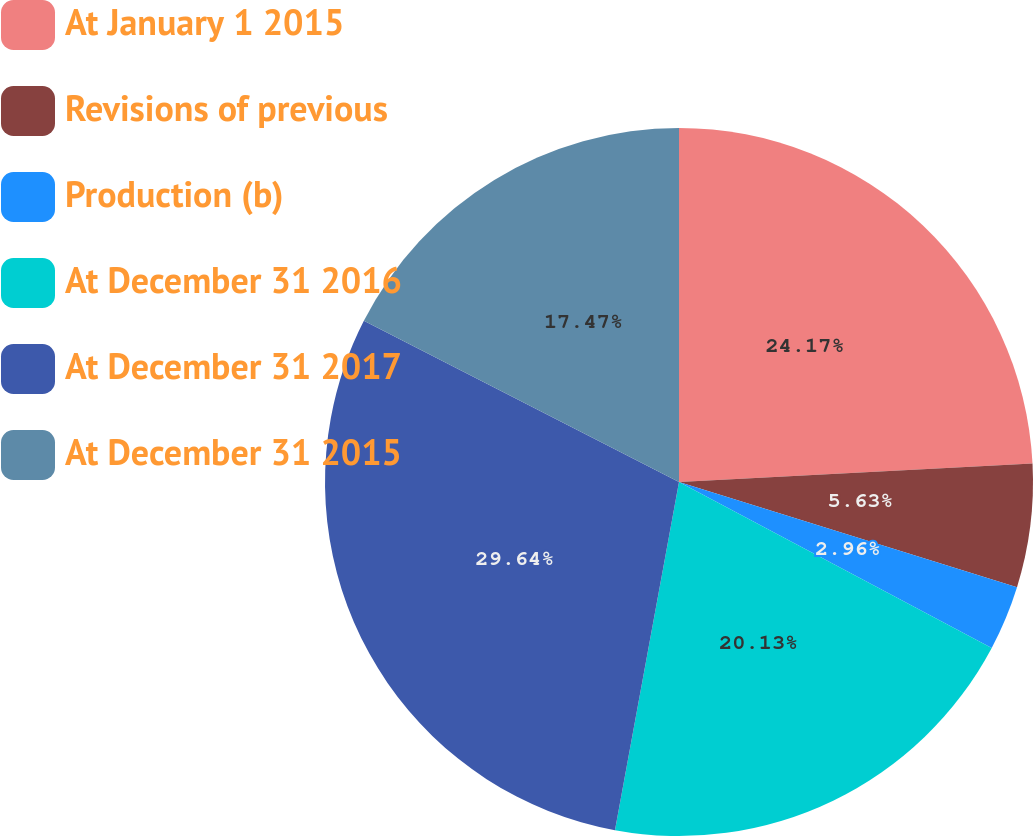<chart> <loc_0><loc_0><loc_500><loc_500><pie_chart><fcel>At January 1 2015<fcel>Revisions of previous<fcel>Production (b)<fcel>At December 31 2016<fcel>At December 31 2017<fcel>At December 31 2015<nl><fcel>24.17%<fcel>5.63%<fcel>2.96%<fcel>20.13%<fcel>29.63%<fcel>17.47%<nl></chart> 